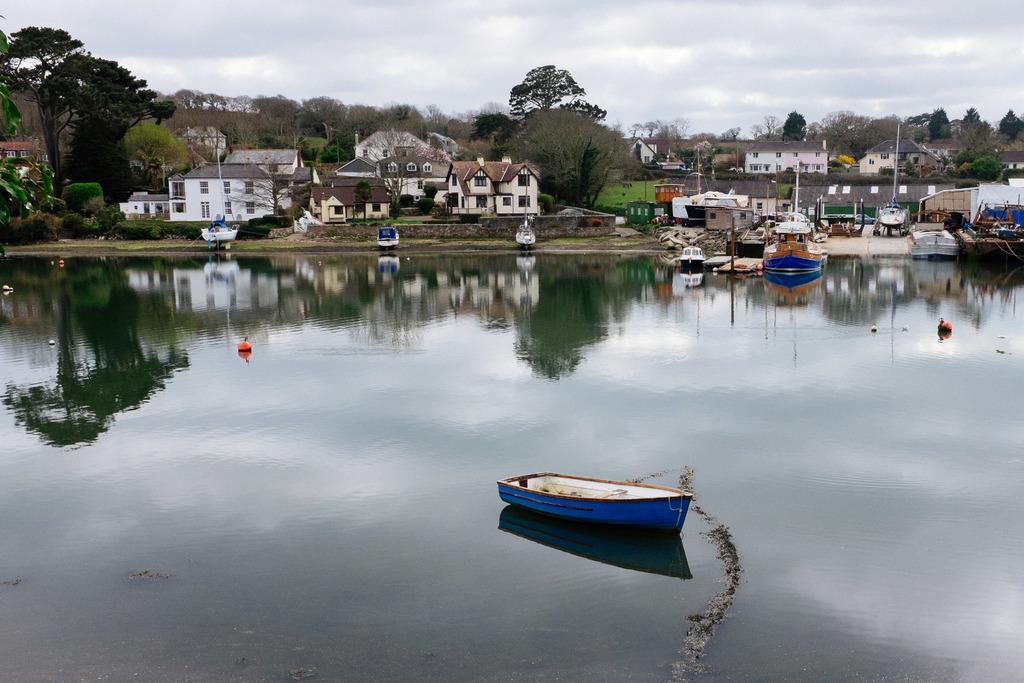In one or two sentences, can you explain what this image depicts? In this image I can see water in the front and on it I can see few boats and few orange colour things. In the background I can see number of boats, number of buildings, number of trees, clouds and the sky. I can also see reflection on the water. 